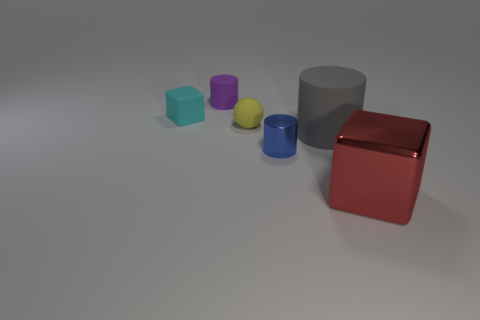How many small objects are either red blocks or green rubber cylinders?
Your answer should be very brief. 0. What is the shape of the tiny cyan thing that is made of the same material as the yellow sphere?
Your answer should be compact. Cube. Are there fewer tiny cyan objects on the left side of the gray cylinder than small purple cylinders?
Provide a short and direct response. No. Is the big red shiny object the same shape as the tiny metal thing?
Provide a succinct answer. No. How many metallic things are tiny green blocks or tiny purple objects?
Provide a short and direct response. 0. Are there any gray cylinders of the same size as the red block?
Give a very brief answer. Yes. What number of purple matte objects are the same size as the rubber block?
Offer a very short reply. 1. There is a cube that is left of the big shiny cube; does it have the same size as the matte cylinder on the right side of the small purple object?
Your answer should be compact. No. What number of objects are either big red matte cylinders or objects that are in front of the tiny yellow sphere?
Provide a short and direct response. 3. What is the color of the tiny shiny thing?
Provide a short and direct response. Blue. 